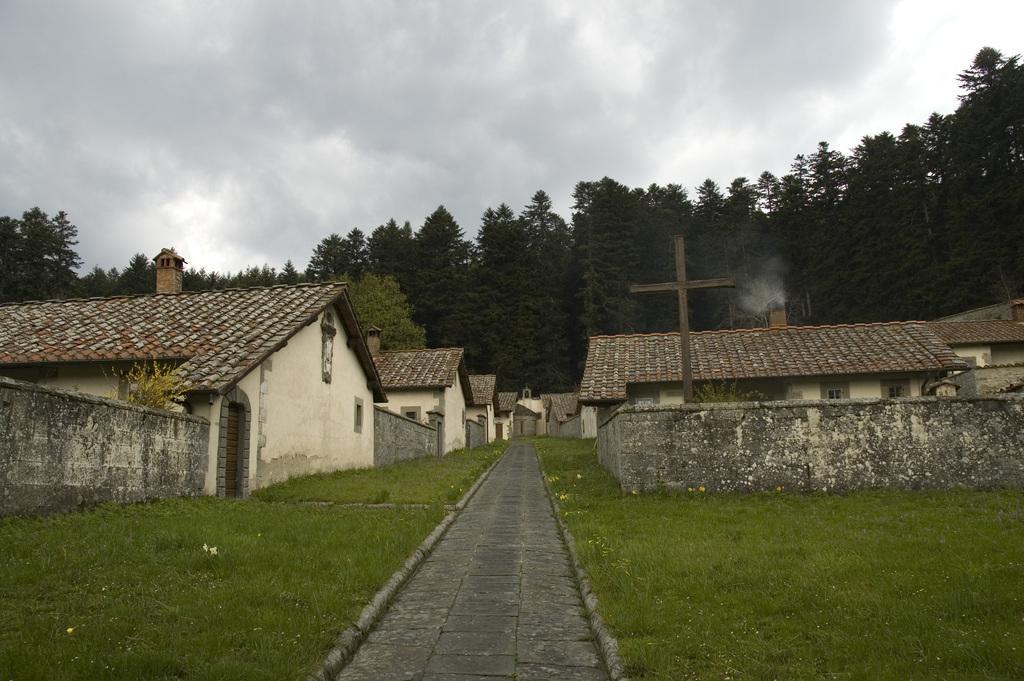Describe this image in one or two sentences. In this image on the right side and left side there are houses, wall, plants, and at the bottom there is grass and walkway. And in the background there are trees, at the top the sky is cloudy. 